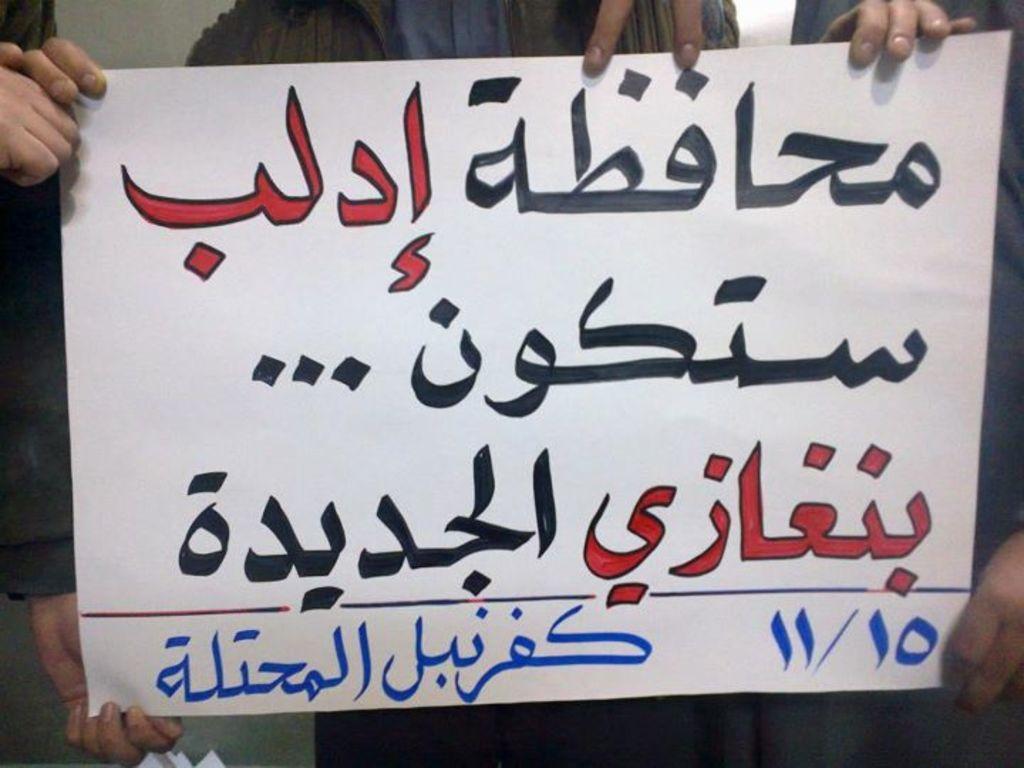Could you give a brief overview of what you see in this image? This looks like a paper with the Urdu letters written on it. In the background, I can see few people holding this paper. 